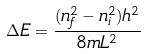Convert formula to latex. <formula><loc_0><loc_0><loc_500><loc_500>\Delta E = { \frac { ( n _ { f } ^ { 2 } - n _ { i } ^ { 2 } ) h ^ { 2 } } { 8 m L ^ { 2 } } }</formula> 